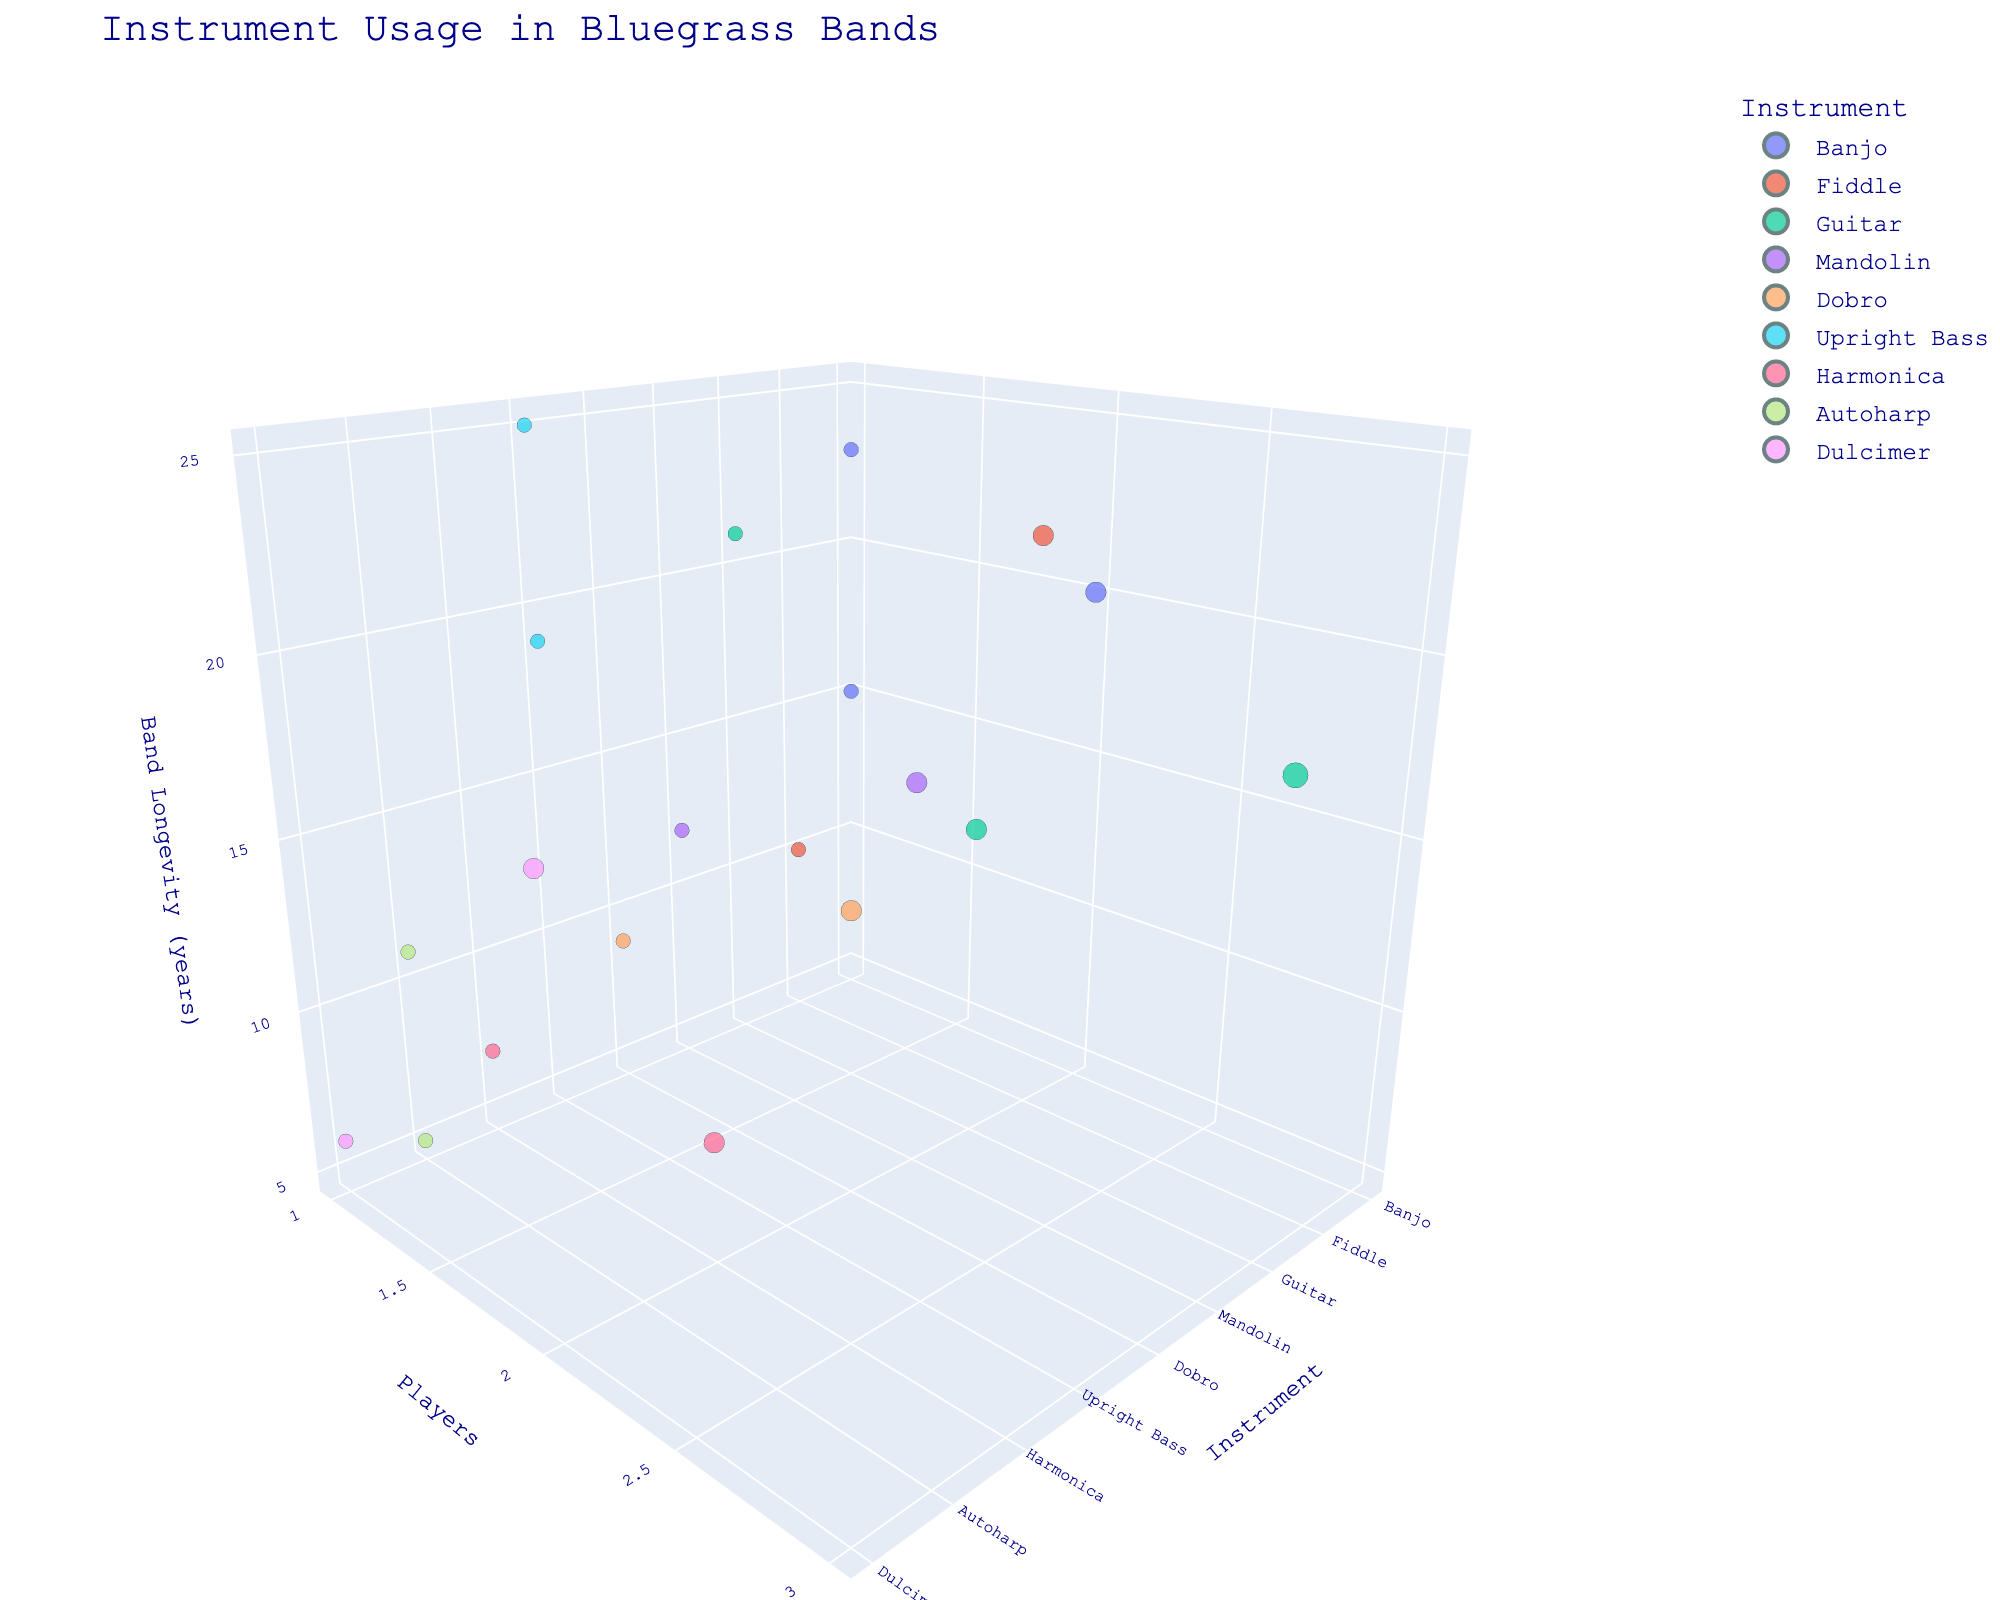How many instruments are represented in the figure? By counting each unique instrument name listed along the x-axis, we can find the total number of different instruments shown in the plot.
Answer: 9 Which instrument is associated with the longest band longevity? By examining the z-axis labeled 'Band Longevity (years)', we look for the data point that is the highest on this axis. This point corresponds to the 'Upright Bass' with a longevity of 25 years.
Answer: Upright Bass Which instrument has the lowest number of players most frequently? By looking at the y-axis labeled 'Players' and identifying the number of data points at the lowest values, it becomes evident that most instruments typically have one player. 'Harmonica' appears most frequently with one player.
Answer: Harmonica Compare the band longevity of the bands with one Banjo player versus those with two Banjo players. Which one is higher? Observing the plot for Banjo data points, we can find one data point with 1 player having a longevity of 15 and 23 years. The data point with 2 players has a longevity of 20 years. Comparing these, the highest is 23 years for one Banjo player.
Answer: One Banjo player Which instruments have a band longevity of less than 10 years? By examining the z-axis and identifying the data points below the 10-year mark, the instruments are 'Dobro,' 'Harmonica,' 'Autoharp,' and 'Dulcimer.'
Answer: Dobro, Harmonica, Autoharp, Dulcimer What is the average band longevity for all instruments with exactly one player? Identifying the data points where the y-axis value is 1, we sum their longevities (15 + 12 + 9 + 25 + 7 + 11 + 6 + 10 + 21 + 23), then divide by the number of such points (10). The calculation is (15+12+9+25+7+11+6+10+21+23) / 10 = 139 / 10.
Answer: 13.9 years Which instrument with exactly two players has the lowest band longevity? By locating the points on the plot with a player count of 2 and examining the 'Band Longevity (years)' values, we identify that the 'Harmonica' has the lowest longevity with 8 years.
Answer: Harmonica Which instruments have data points at multiple different player counts? Observing the plot, we can see that 'Banjo,' 'Fiddle,' 'Guitar,' 'Mandolin,' 'Dobro,' 'Harmonica,' 'Autoharp,' and 'Dulcimer' have data points at both one or two players.
Answer: Banjo, Fiddle, Guitar, Mandolin, Dobro, Harmonica, Autoharp, Dulcimer How does the size of the data points relate to the number of players? Larger data points are used to indicate bands with two players, while smaller points correspond to one player. The size of markers reflects the 'Players' value on the y-axis.
Answer: Larger points mean more players Is there an instrument that appears to have consistent band longevity regardless of the number of players? Reviewing the available data, the 'Guitar' doesn't have widely varying longevities (18, 14, and 21 years) across its player counts, showing a relatively consistent range.
Answer: Guitar 